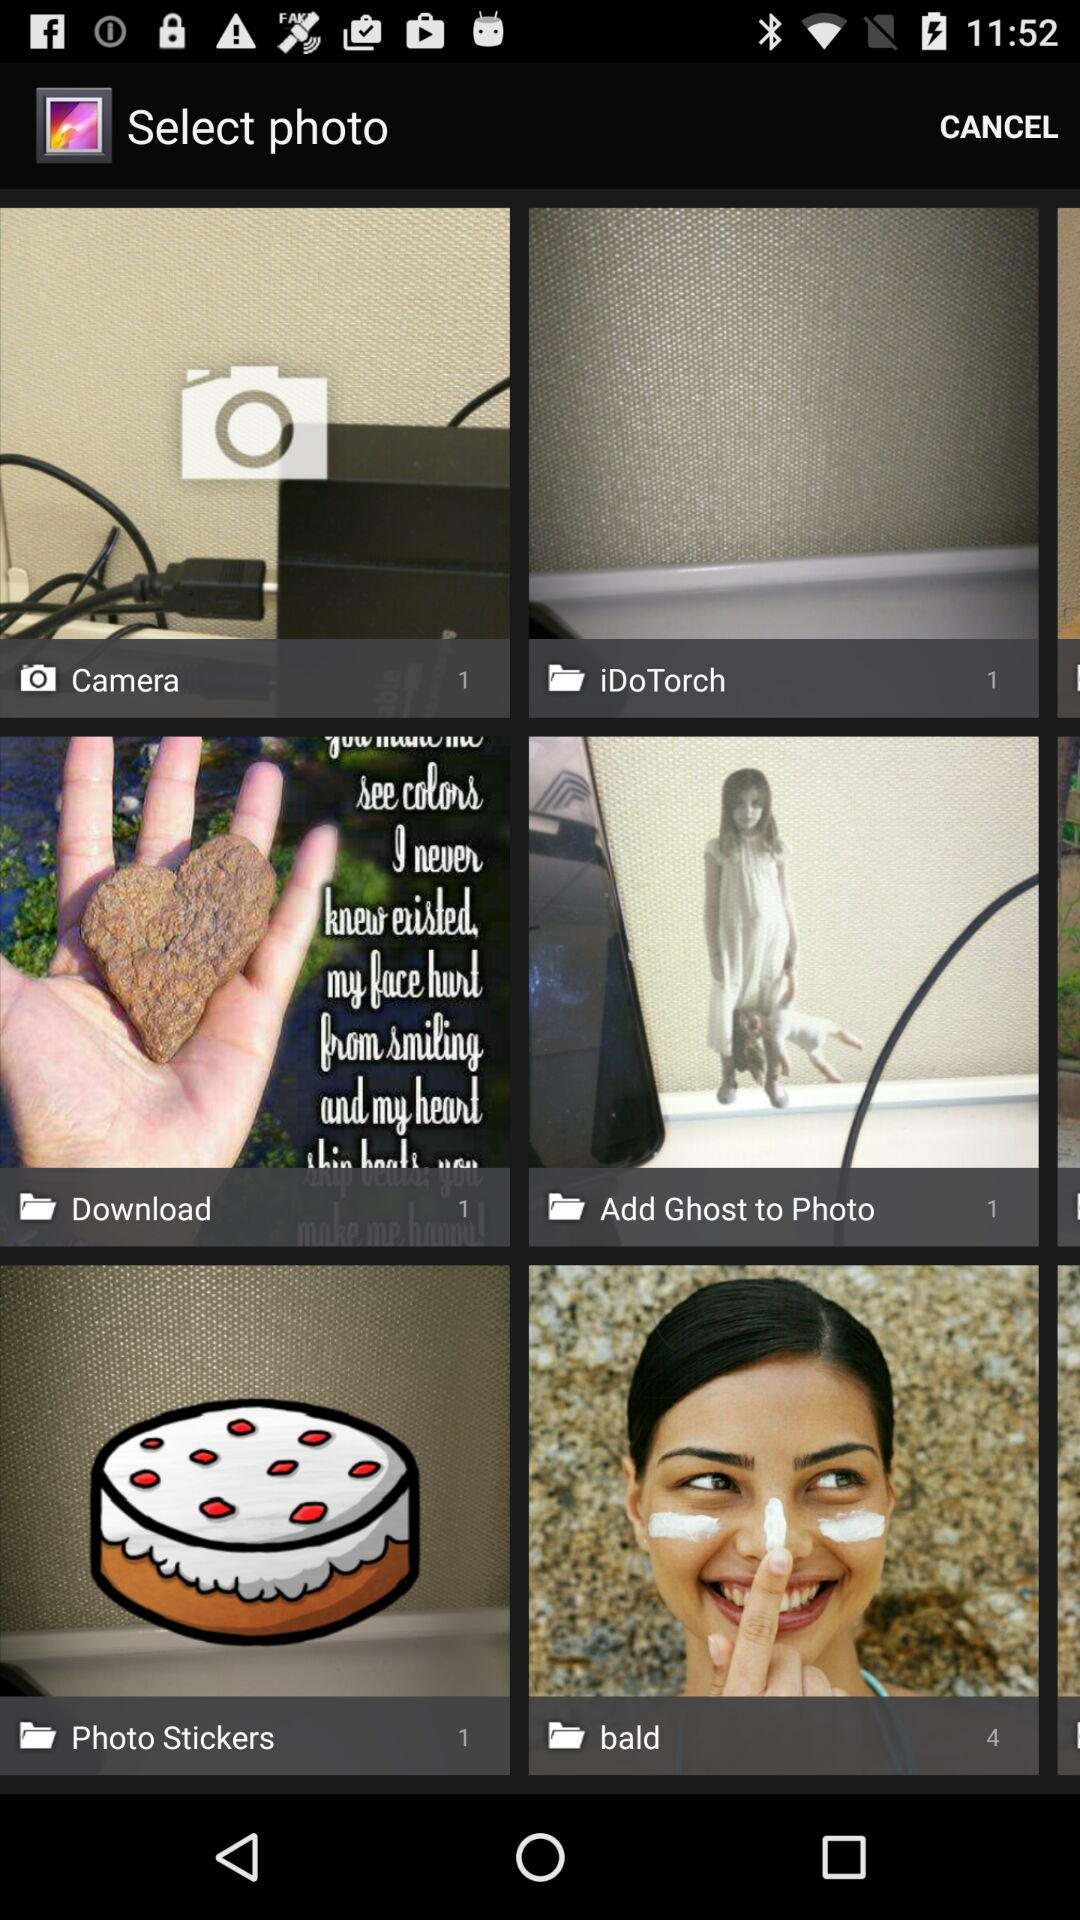What is the number of pictures in the "Camera" folder? The number of pictures in the "Camera" folder is 1. 